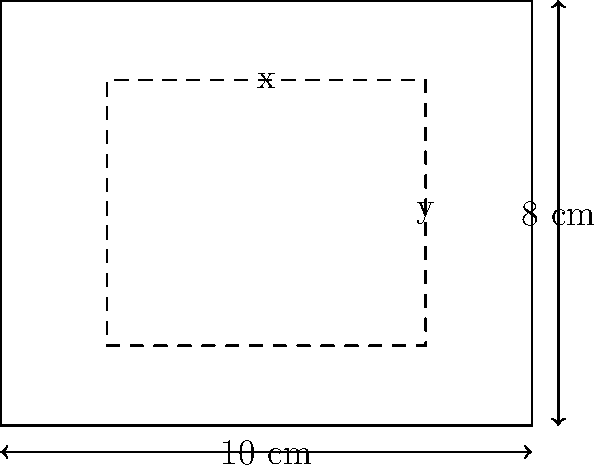As a stagehand, you're tasked with creating a hidden compartment within a rectangular prop. The prop's outer dimensions are 10 cm wide and 8 cm tall. You want to maximize the area of the hidden compartment while maintaining a minimum border thickness of 2 cm on all sides. What are the optimal dimensions (width and height) of the hidden compartment to maximize its area? Let's approach this step-by-step:

1) Let $x$ be the width and $y$ be the height of the hidden compartment.

2) Given the constraints:
   - Prop width: 10 cm
   - Prop height: 8 cm
   - Minimum border thickness: 2 cm on all sides

3) We can express the constraints mathematically:
   $x \leq 10 - 2 - 2 = 6$ cm (width)
   $y \leq 8 - 2 - 2 = 4$ cm (height)

4) The area of the hidden compartment is given by $A = xy$

5) To maximize the area, we should use the maximum possible dimensions:
   $x = 6$ cm
   $y = 4$ cm

6) Verify the maximum area:
   $A_{max} = xy = 6 \times 4 = 24$ cm²

Therefore, the optimal dimensions for the hidden compartment are 6 cm wide and 4 cm tall, which will yield the maximum possible area of 24 cm² while maintaining the required 2 cm border on all sides.
Answer: 6 cm wide, 4 cm tall 